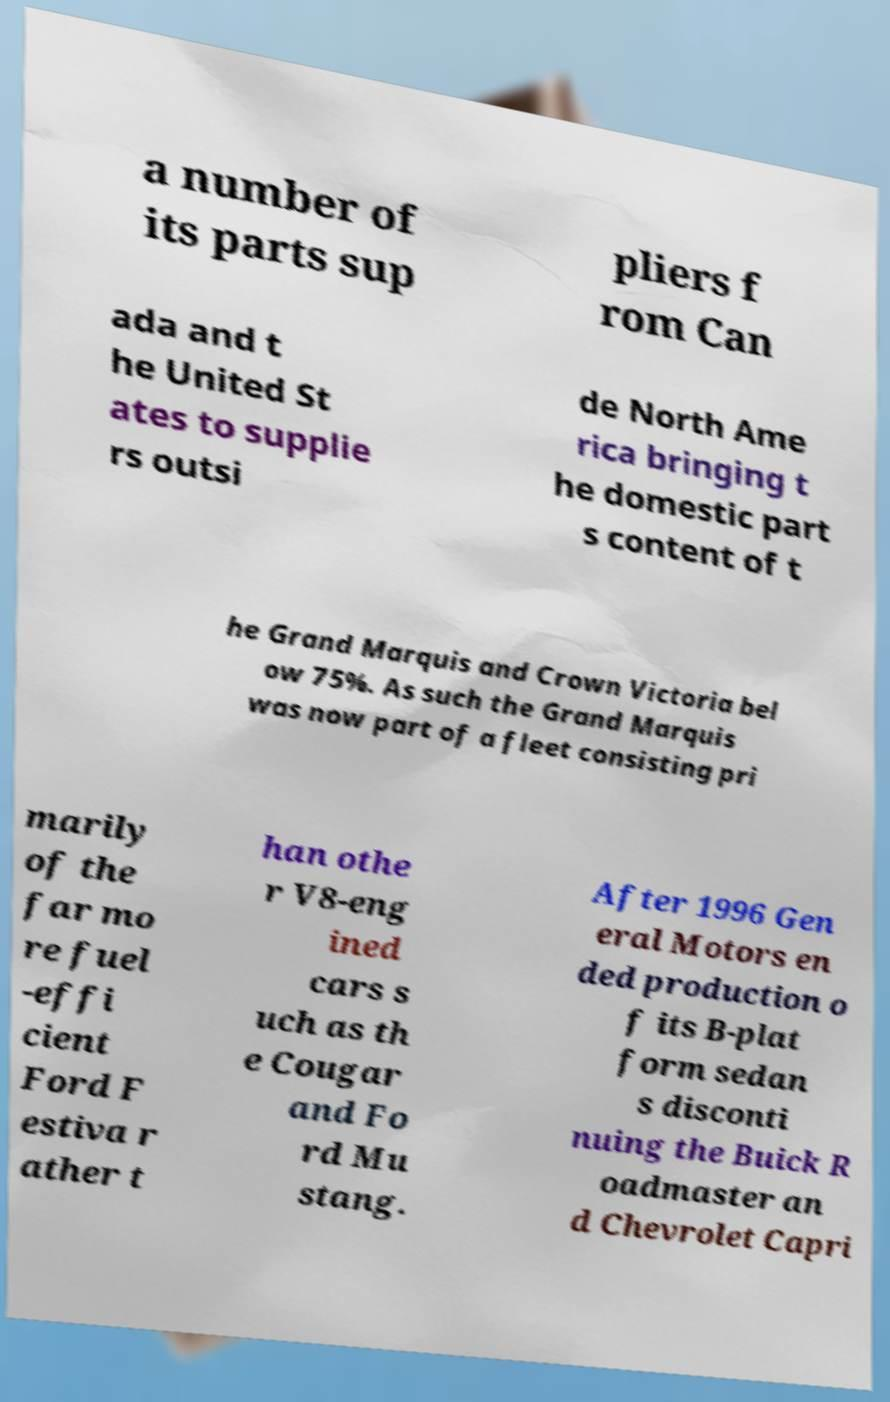Could you assist in decoding the text presented in this image and type it out clearly? a number of its parts sup pliers f rom Can ada and t he United St ates to supplie rs outsi de North Ame rica bringing t he domestic part s content of t he Grand Marquis and Crown Victoria bel ow 75%. As such the Grand Marquis was now part of a fleet consisting pri marily of the far mo re fuel -effi cient Ford F estiva r ather t han othe r V8-eng ined cars s uch as th e Cougar and Fo rd Mu stang. After 1996 Gen eral Motors en ded production o f its B-plat form sedan s disconti nuing the Buick R oadmaster an d Chevrolet Capri 